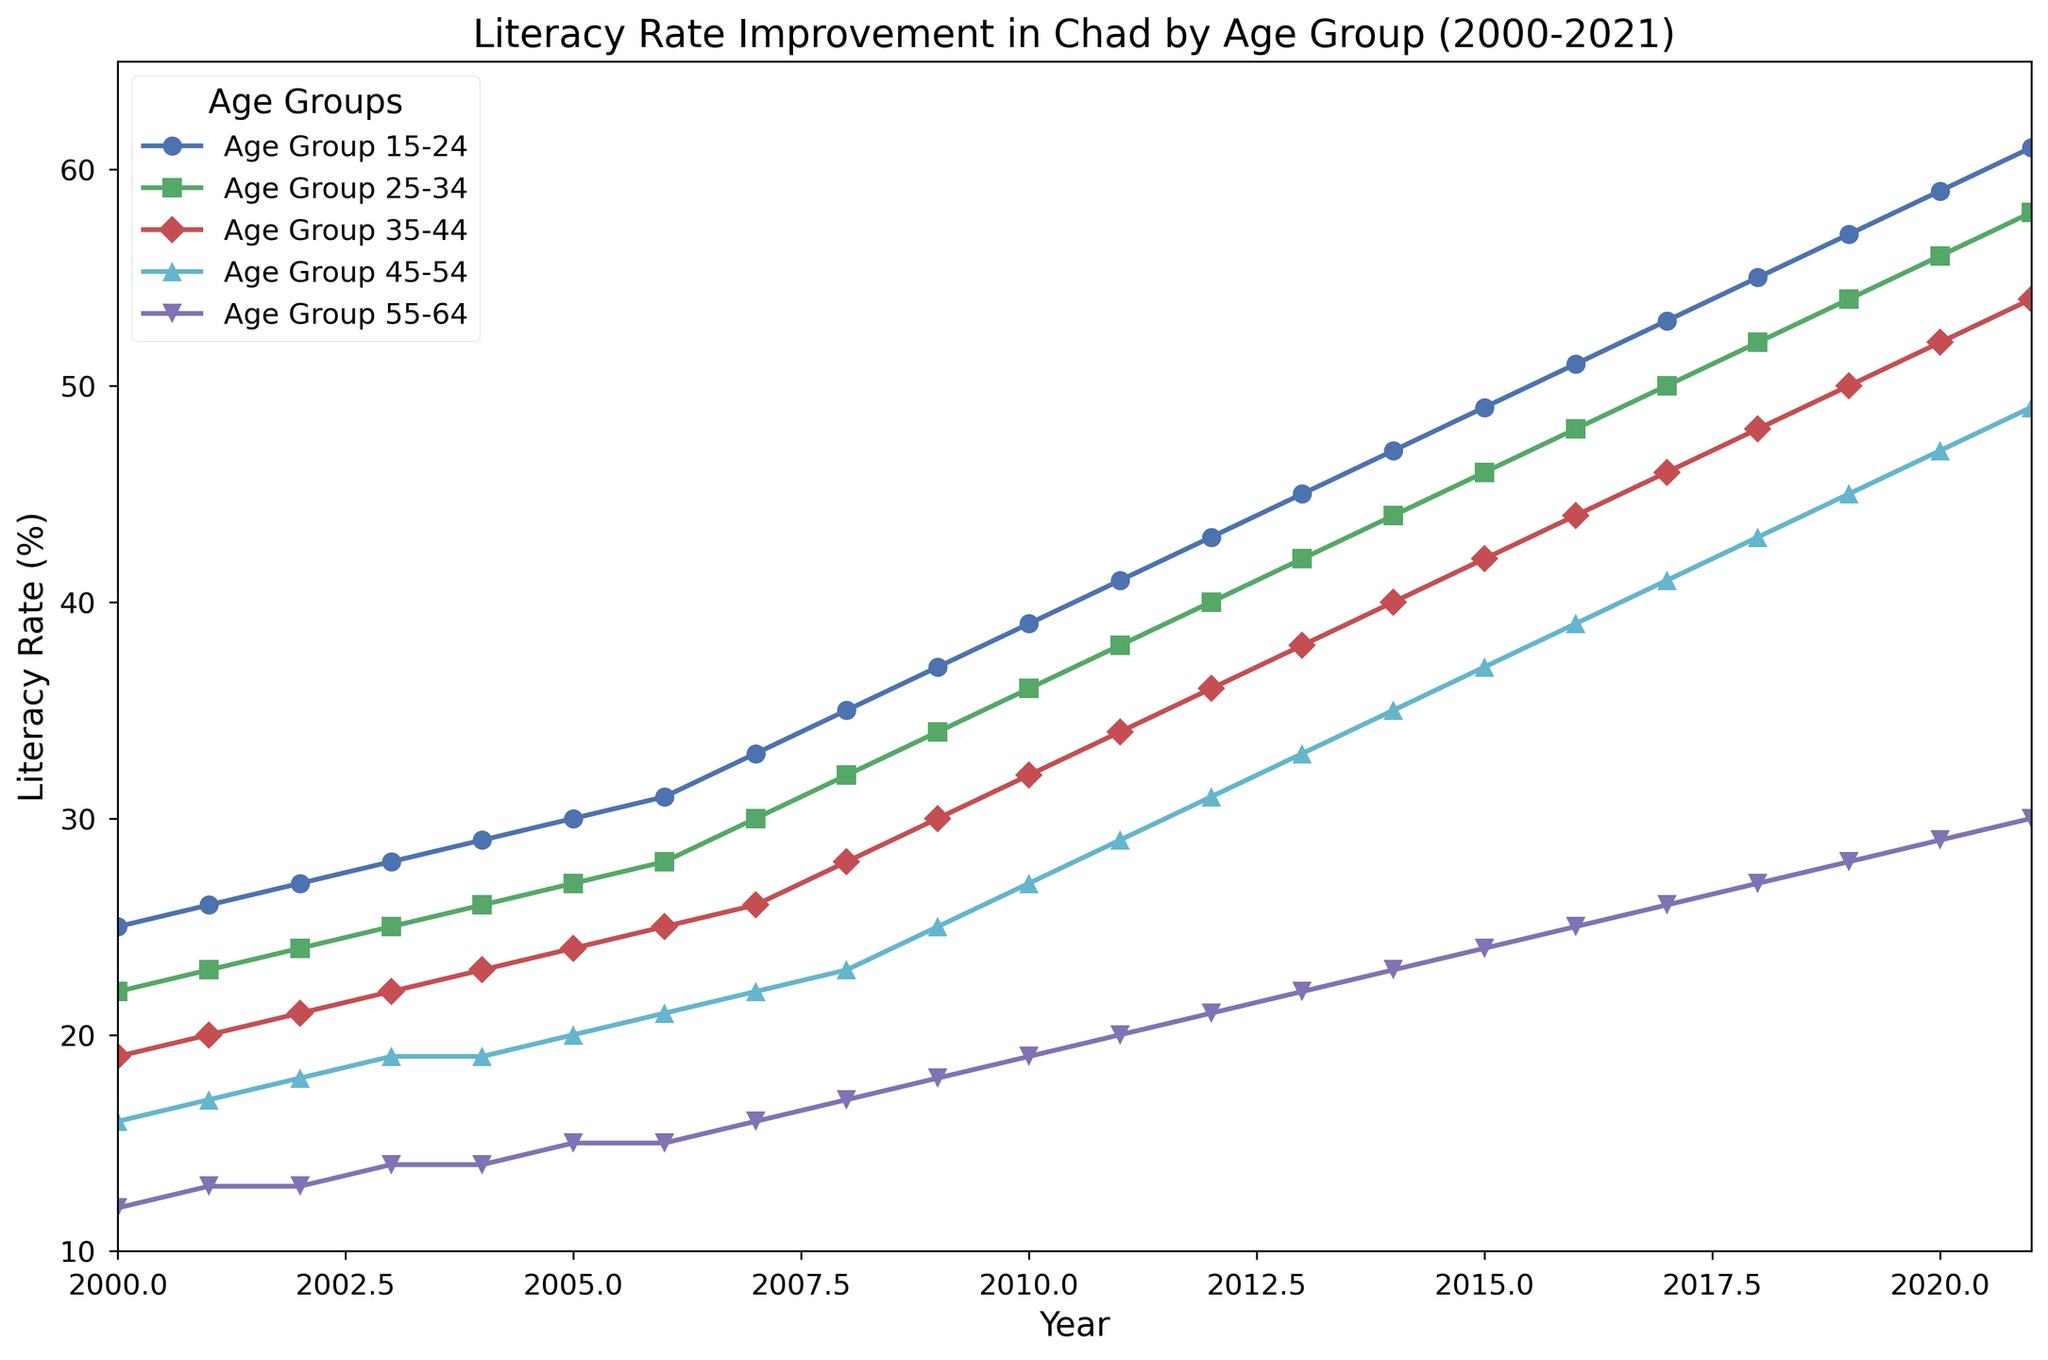what is the overall trend for the literacy rate in the 15-24 age group from 2000 to 2021? The literacy rate for the 15-24 age group shows a steady increase from 25% in 2000 to 61% in 2021, indicating continuous improvement over the years.
Answer: Steady increase Which age group had the smallest literacy rate in 2000? By observing the figure, we can see that the 55-64 age group had the smallest literacy rate in 2000, starting at 12%.
Answer: 55-64 age group Among the age groups shown, which had the greatest improvement in literacy rate over the span of 2000 to 2021? To determine the greatest improvement, we can compare the start and end literacy rates for each age group. The 15-24 age group improved from 25% to 61%, an increase of 36 percentage points, which is the greatest improvement among all age groups.
Answer: 15-24 age group In which year did the 15-24 age group's literacy rate reach 50%? Observing the 15-24 age group line, we can see it crosses the 50% mark in 2017.
Answer: 2017 Compare the literacy rate improvement of the 25-34 age group to that of the 45-54 age group between 2010 and 2020. For the 25-34 age group, the literacy rate increased from 36% in 2010 to 56% in 2020, an improvement of 20 percentage points. For the 45-54 age group, the literacy rate increased from 27% in 2010 to 47% in 2020, also an improvement of 20 percentage points.
Answer: Both improved by 20 percentage points How much higher was the literacy rate for the 15-24 age group compared to the 55-64 age group in 2021? In 2021, the literacy rate for the 15-24 age group was 61%, and for the 55-64 age group, it was 30%. The difference is 61% - 30% = 31 percentage points.
Answer: 31 percentage points What is the average literacy rate of the age group 35-44 for the years 2000 to 2005? The literacy rates for the 35-44 age group from 2000 to 2005 are 19%, 20%, 21%, 22%, 23%, and 24%. Adding them gives 129. The average is 129/6 = 21.5%.
Answer: 21.5% Which age group had the least improvement in literacy rates from 2000 to 2021? By comparing the improvement across age groups, the 55-64 age group had the smallest jump, from 12% in 2000 to 30% in 2021, an increase of only 18 percentage points.
Answer: 55-64 age group 